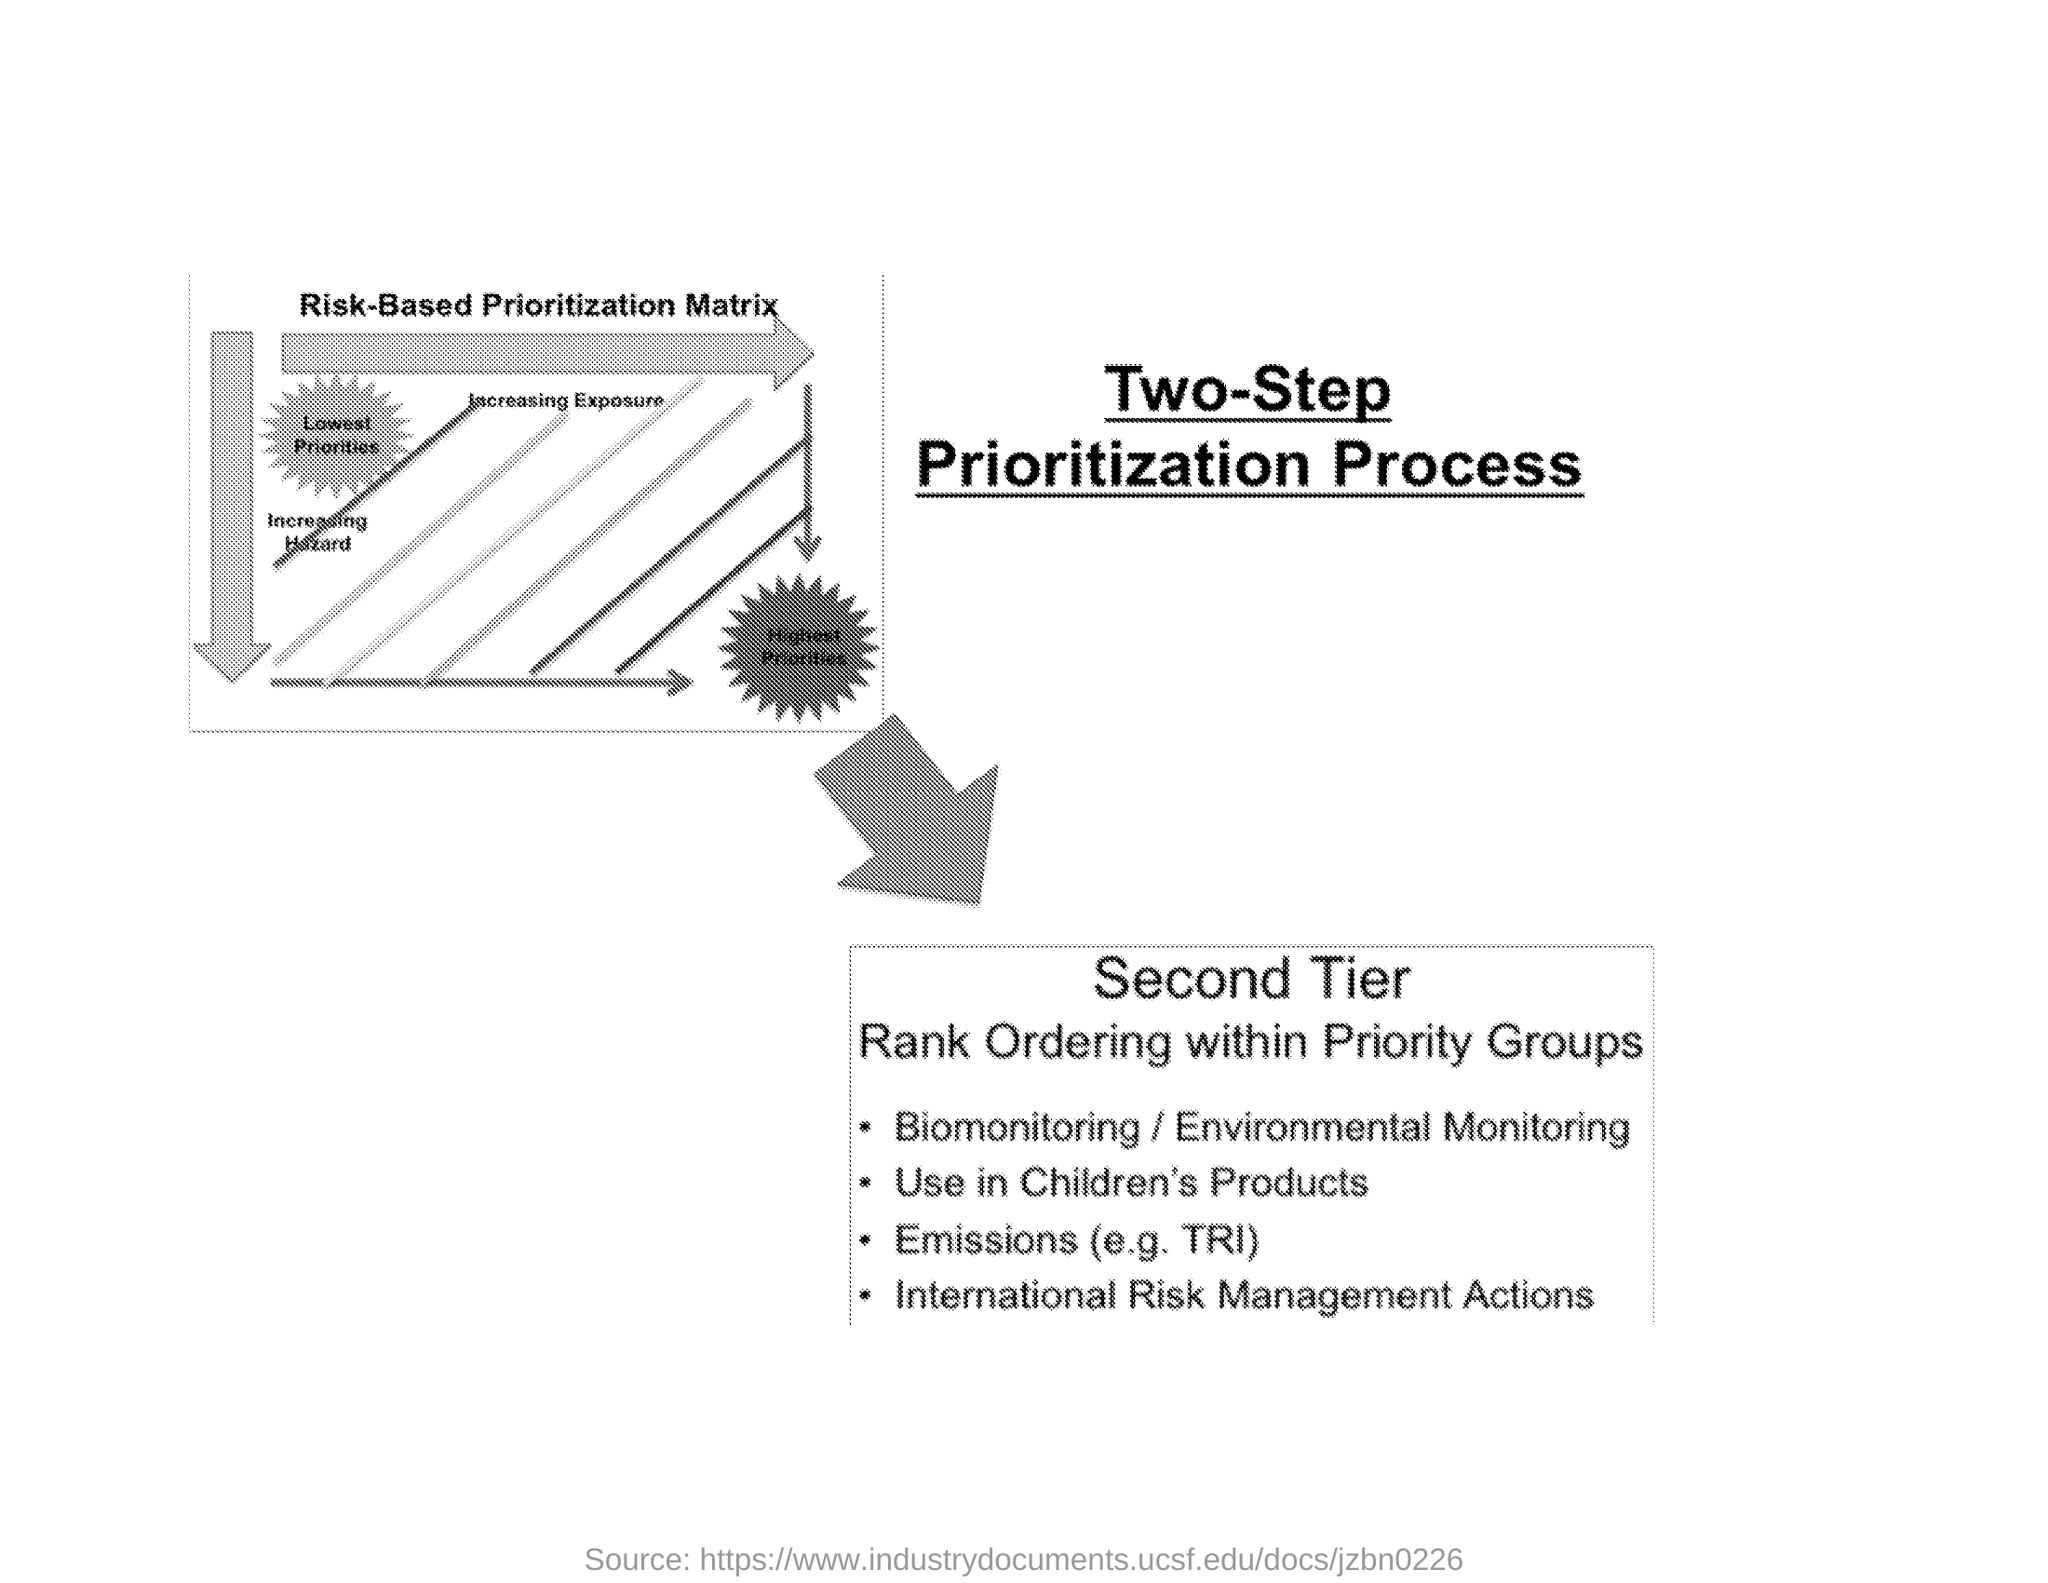How many steps Prioritization Process is shown?
Provide a short and direct response. Two-Step. In the Second Tier the Ranking Ordering are within which groups?
Your answer should be compact. Priority Groups. What is the heading of the picture shown?
Provide a short and direct response. Risk-Based Prioritization Matrix. What is the alternative given for Biomonitoring?
Your answer should be very brief. Environmental Monitoring. 